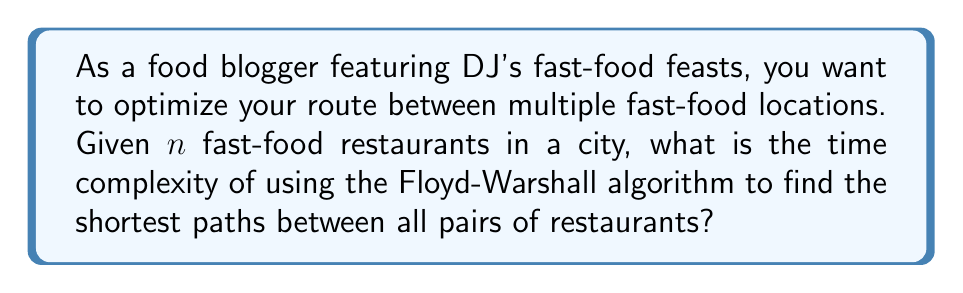Teach me how to tackle this problem. To solve this problem, let's break it down step-by-step:

1. The Floyd-Warshall algorithm is used to find the shortest paths between all pairs of vertices in a weighted graph.

2. In our case, the vertices represent fast-food restaurants, and the edges represent the routes between them.

3. The Floyd-Warshall algorithm works as follows:
   - It uses a dynamic programming approach.
   - It considers all vertices as intermediate vertices one by one.
   - For each pair of vertices (i, j), it checks if the path through the current intermediate vertex k is shorter than the known path.

4. The algorithm uses three nested loops:
   - The outermost loop iterates through all vertices as potential intermediate vertices.
   - The two inner loops consider all pairs of vertices.

5. The time complexity analysis:
   - Each of the three loops runs $n$ times, where $n$ is the number of vertices (fast-food restaurants in our case).
   - Inside the innermost loop, we perform a constant number of operations.

6. Therefore, the total number of operations is proportional to $n \times n \times n = n^3$.

7. In Big O notation, we express this as $O(n^3)$.

This means that as the number of fast-food restaurants increases, the time taken by the algorithm increases cubically.
Answer: The time complexity of using the Floyd-Warshall algorithm to find the shortest paths between all pairs of $n$ fast-food restaurants is $O(n^3)$. 